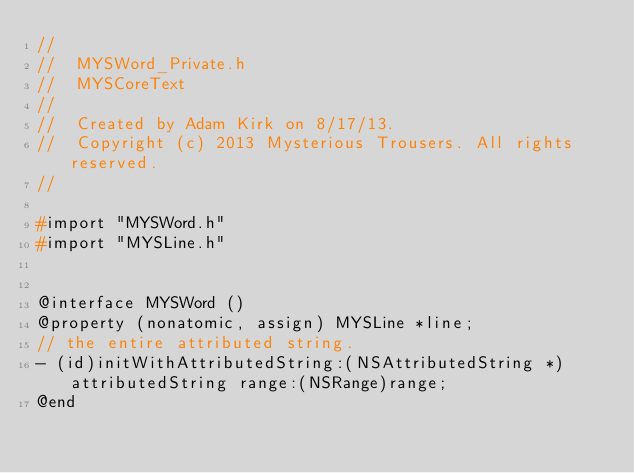<code> <loc_0><loc_0><loc_500><loc_500><_C_>//
//  MYSWord_Private.h
//  MYSCoreText
//
//  Created by Adam Kirk on 8/17/13.
//  Copyright (c) 2013 Mysterious Trousers. All rights reserved.
//

#import "MYSWord.h"
#import "MYSLine.h"


@interface MYSWord ()
@property (nonatomic, assign) MYSLine *line;
// the entire attributed string.
- (id)initWithAttributedString:(NSAttributedString *)attributedString range:(NSRange)range;
@end</code> 